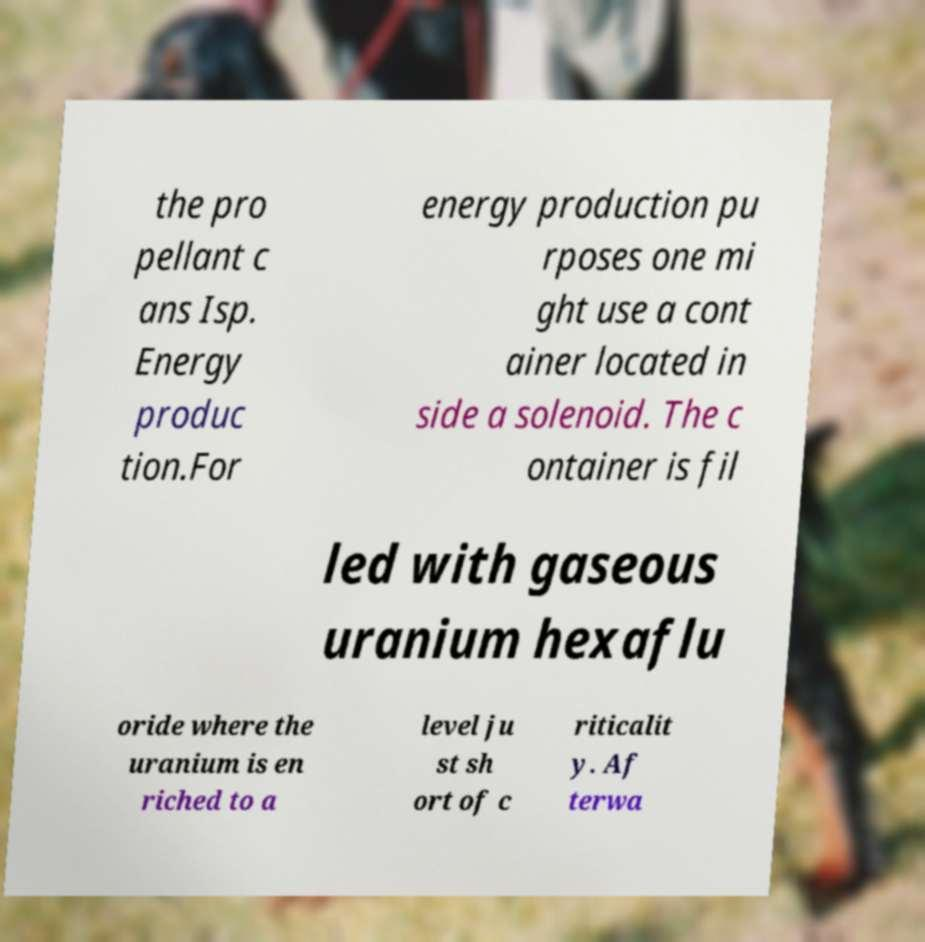Can you read and provide the text displayed in the image?This photo seems to have some interesting text. Can you extract and type it out for me? the pro pellant c ans Isp. Energy produc tion.For energy production pu rposes one mi ght use a cont ainer located in side a solenoid. The c ontainer is fil led with gaseous uranium hexaflu oride where the uranium is en riched to a level ju st sh ort of c riticalit y. Af terwa 